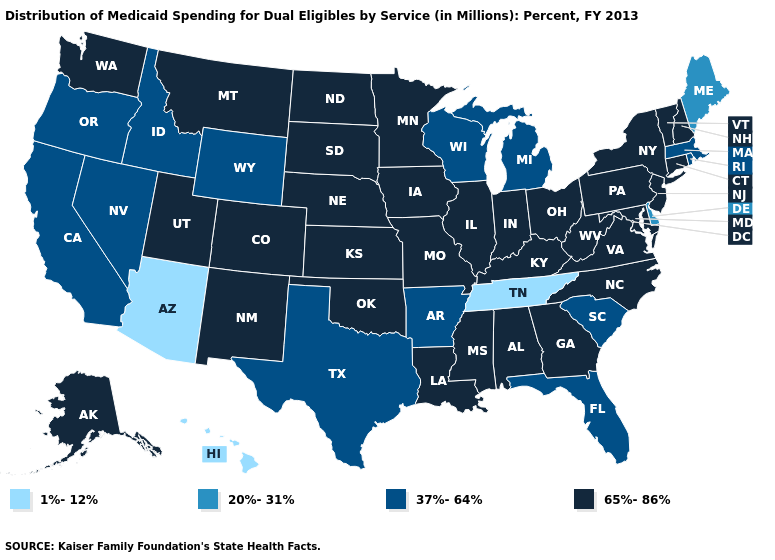Does the map have missing data?
Be succinct. No. Does the first symbol in the legend represent the smallest category?
Quick response, please. Yes. What is the value of Oregon?
Concise answer only. 37%-64%. Name the states that have a value in the range 65%-86%?
Give a very brief answer. Alabama, Alaska, Colorado, Connecticut, Georgia, Illinois, Indiana, Iowa, Kansas, Kentucky, Louisiana, Maryland, Minnesota, Mississippi, Missouri, Montana, Nebraska, New Hampshire, New Jersey, New Mexico, New York, North Carolina, North Dakota, Ohio, Oklahoma, Pennsylvania, South Dakota, Utah, Vermont, Virginia, Washington, West Virginia. Which states have the lowest value in the USA?
Give a very brief answer. Arizona, Hawaii, Tennessee. How many symbols are there in the legend?
Write a very short answer. 4. Does the map have missing data?
Quick response, please. No. Name the states that have a value in the range 37%-64%?
Keep it brief. Arkansas, California, Florida, Idaho, Massachusetts, Michigan, Nevada, Oregon, Rhode Island, South Carolina, Texas, Wisconsin, Wyoming. What is the value of Illinois?
Keep it brief. 65%-86%. What is the value of Oregon?
Write a very short answer. 37%-64%. Name the states that have a value in the range 1%-12%?
Write a very short answer. Arizona, Hawaii, Tennessee. What is the value of Ohio?
Answer briefly. 65%-86%. What is the value of North Carolina?
Quick response, please. 65%-86%. Which states have the lowest value in the USA?
Concise answer only. Arizona, Hawaii, Tennessee. Name the states that have a value in the range 20%-31%?
Short answer required. Delaware, Maine. 